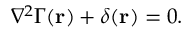<formula> <loc_0><loc_0><loc_500><loc_500>\nabla ^ { 2 } \Gamma ( r ) + \delta ( r ) = 0 .</formula> 